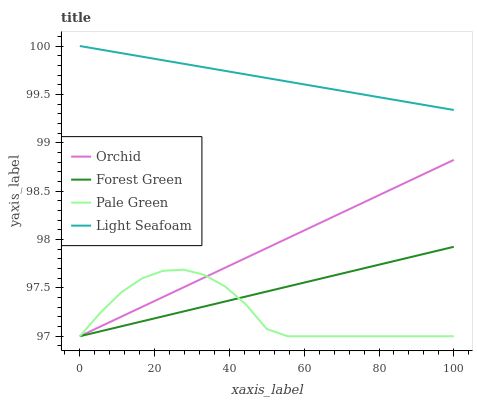Does Pale Green have the minimum area under the curve?
Answer yes or no. Yes. Does Light Seafoam have the maximum area under the curve?
Answer yes or no. Yes. Does Light Seafoam have the minimum area under the curve?
Answer yes or no. No. Does Pale Green have the maximum area under the curve?
Answer yes or no. No. Is Orchid the smoothest?
Answer yes or no. Yes. Is Pale Green the roughest?
Answer yes or no. Yes. Is Light Seafoam the smoothest?
Answer yes or no. No. Is Light Seafoam the roughest?
Answer yes or no. No. Does Forest Green have the lowest value?
Answer yes or no. Yes. Does Light Seafoam have the lowest value?
Answer yes or no. No. Does Light Seafoam have the highest value?
Answer yes or no. Yes. Does Pale Green have the highest value?
Answer yes or no. No. Is Pale Green less than Light Seafoam?
Answer yes or no. Yes. Is Light Seafoam greater than Forest Green?
Answer yes or no. Yes. Does Forest Green intersect Pale Green?
Answer yes or no. Yes. Is Forest Green less than Pale Green?
Answer yes or no. No. Is Forest Green greater than Pale Green?
Answer yes or no. No. Does Pale Green intersect Light Seafoam?
Answer yes or no. No. 